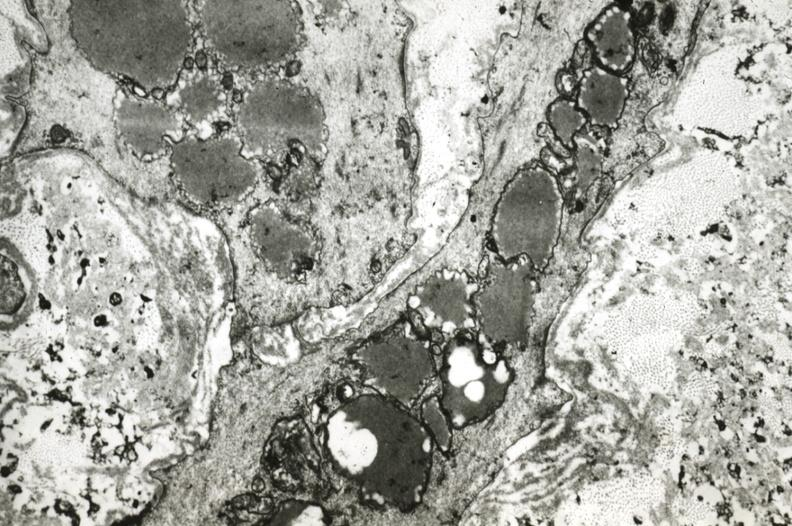what is present?
Answer the question using a single word or phrase. Cardiovascular 